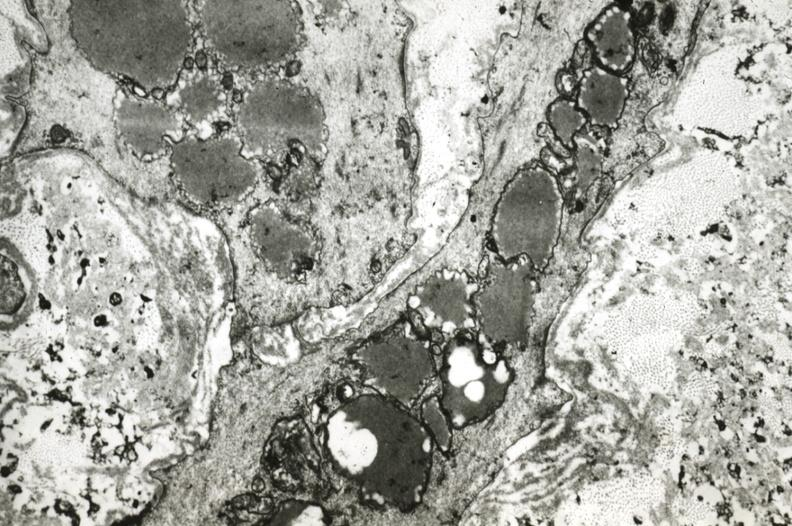what is present?
Answer the question using a single word or phrase. Cardiovascular 